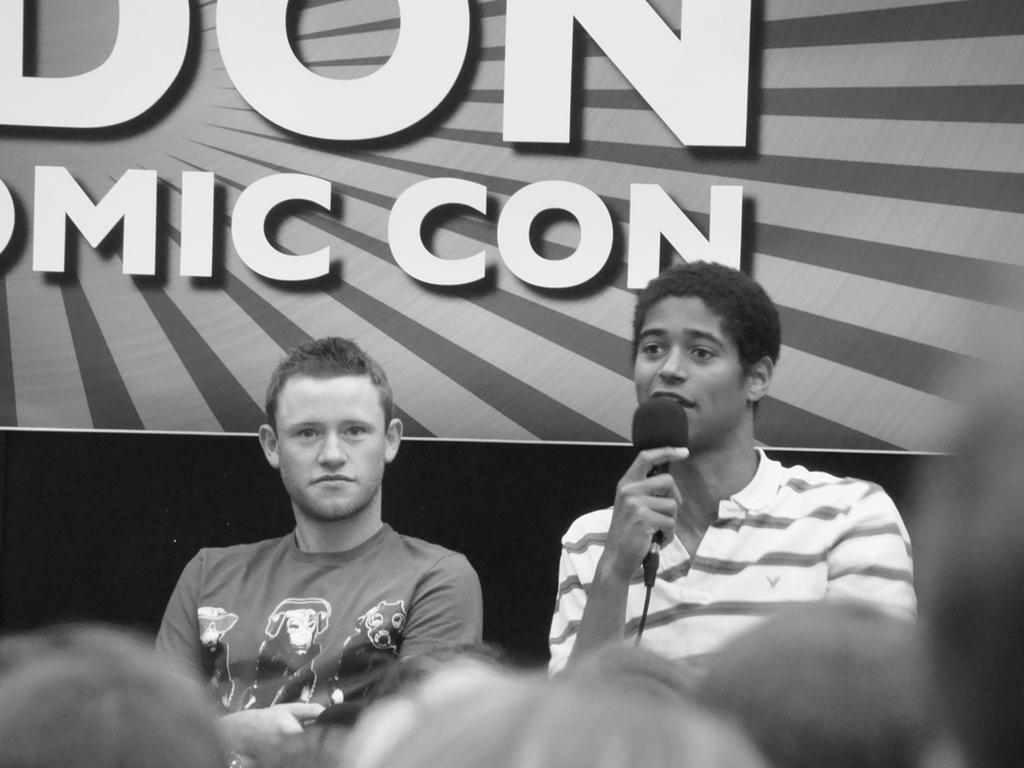How many people are in the image? There are two men in the image. What is one of the men holding? One of the men is holding a microphone. What grade does the monkey receive in the image? There is no monkey present in the image, so it is not possible to determine a grade for a monkey. 